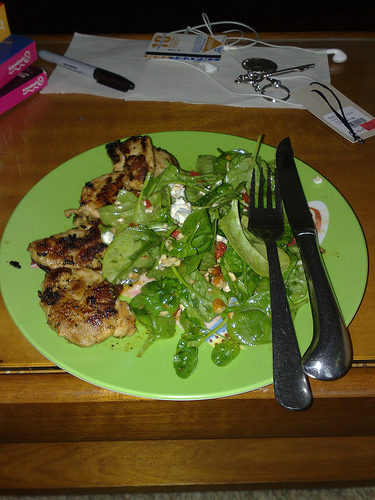<image>
Can you confirm if the pen is on the plate? No. The pen is not positioned on the plate. They may be near each other, but the pen is not supported by or resting on top of the plate. Where is the pen in relation to the keys? Is it next to the keys? Yes. The pen is positioned adjacent to the keys, located nearby in the same general area. Is there a marker above the plate? No. The marker is not positioned above the plate. The vertical arrangement shows a different relationship. 